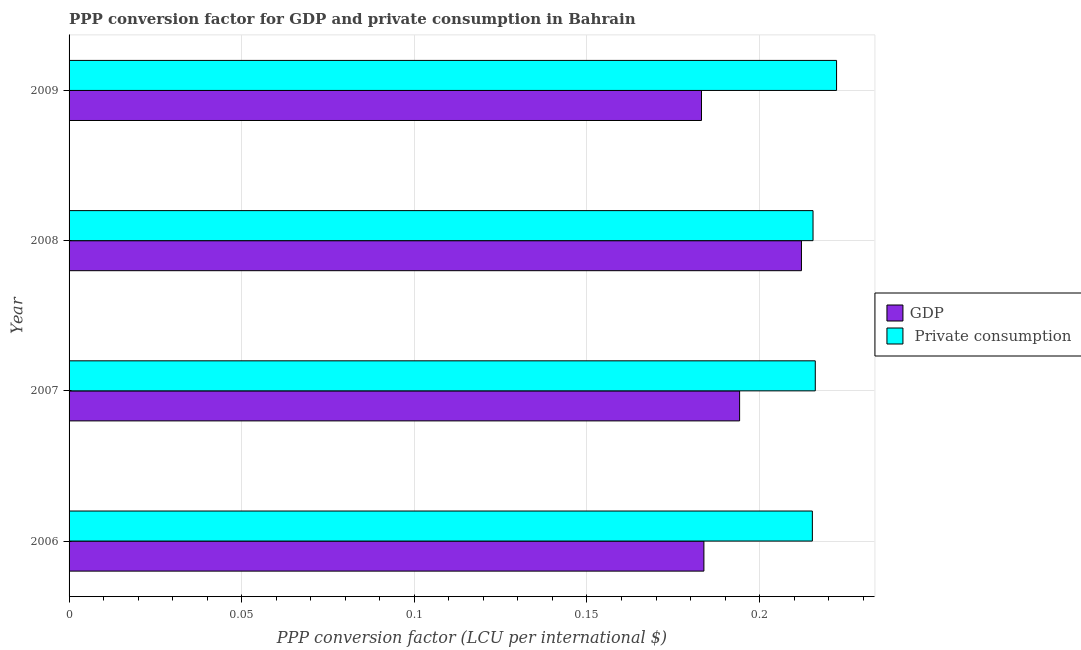How many different coloured bars are there?
Offer a terse response. 2. How many bars are there on the 2nd tick from the bottom?
Your answer should be very brief. 2. In how many cases, is the number of bars for a given year not equal to the number of legend labels?
Keep it short and to the point. 0. What is the ppp conversion factor for private consumption in 2006?
Make the answer very short. 0.22. Across all years, what is the maximum ppp conversion factor for private consumption?
Offer a very short reply. 0.22. Across all years, what is the minimum ppp conversion factor for private consumption?
Offer a terse response. 0.22. What is the total ppp conversion factor for gdp in the graph?
Make the answer very short. 0.77. What is the difference between the ppp conversion factor for private consumption in 2007 and that in 2008?
Your response must be concise. 0. What is the difference between the ppp conversion factor for gdp in 2009 and the ppp conversion factor for private consumption in 2006?
Provide a succinct answer. -0.03. What is the average ppp conversion factor for gdp per year?
Provide a short and direct response. 0.19. In the year 2008, what is the difference between the ppp conversion factor for private consumption and ppp conversion factor for gdp?
Your answer should be very brief. 0. What is the ratio of the ppp conversion factor for gdp in 2006 to that in 2009?
Ensure brevity in your answer.  1. Is the ppp conversion factor for gdp in 2007 less than that in 2009?
Your answer should be very brief. No. Is the difference between the ppp conversion factor for gdp in 2008 and 2009 greater than the difference between the ppp conversion factor for private consumption in 2008 and 2009?
Offer a terse response. Yes. What is the difference between the highest and the second highest ppp conversion factor for gdp?
Offer a very short reply. 0.02. What is the difference between the highest and the lowest ppp conversion factor for gdp?
Give a very brief answer. 0.03. In how many years, is the ppp conversion factor for gdp greater than the average ppp conversion factor for gdp taken over all years?
Provide a succinct answer. 2. What does the 2nd bar from the top in 2007 represents?
Provide a short and direct response. GDP. What does the 2nd bar from the bottom in 2006 represents?
Offer a terse response.  Private consumption. What is the difference between two consecutive major ticks on the X-axis?
Your answer should be very brief. 0.05. Does the graph contain any zero values?
Your answer should be compact. No. How many legend labels are there?
Make the answer very short. 2. What is the title of the graph?
Offer a terse response. PPP conversion factor for GDP and private consumption in Bahrain. Does "US$" appear as one of the legend labels in the graph?
Give a very brief answer. No. What is the label or title of the X-axis?
Your response must be concise. PPP conversion factor (LCU per international $). What is the label or title of the Y-axis?
Give a very brief answer. Year. What is the PPP conversion factor (LCU per international $) of GDP in 2006?
Your answer should be very brief. 0.18. What is the PPP conversion factor (LCU per international $) of  Private consumption in 2006?
Your answer should be compact. 0.22. What is the PPP conversion factor (LCU per international $) in GDP in 2007?
Offer a very short reply. 0.19. What is the PPP conversion factor (LCU per international $) of  Private consumption in 2007?
Offer a terse response. 0.22. What is the PPP conversion factor (LCU per international $) of GDP in 2008?
Give a very brief answer. 0.21. What is the PPP conversion factor (LCU per international $) of  Private consumption in 2008?
Ensure brevity in your answer.  0.22. What is the PPP conversion factor (LCU per international $) in GDP in 2009?
Provide a short and direct response. 0.18. What is the PPP conversion factor (LCU per international $) in  Private consumption in 2009?
Your answer should be very brief. 0.22. Across all years, what is the maximum PPP conversion factor (LCU per international $) in GDP?
Offer a terse response. 0.21. Across all years, what is the maximum PPP conversion factor (LCU per international $) of  Private consumption?
Your response must be concise. 0.22. Across all years, what is the minimum PPP conversion factor (LCU per international $) of GDP?
Provide a short and direct response. 0.18. Across all years, what is the minimum PPP conversion factor (LCU per international $) of  Private consumption?
Your answer should be very brief. 0.22. What is the total PPP conversion factor (LCU per international $) of GDP in the graph?
Your response must be concise. 0.77. What is the total PPP conversion factor (LCU per international $) in  Private consumption in the graph?
Your answer should be very brief. 0.87. What is the difference between the PPP conversion factor (LCU per international $) in GDP in 2006 and that in 2007?
Make the answer very short. -0.01. What is the difference between the PPP conversion factor (LCU per international $) in  Private consumption in 2006 and that in 2007?
Provide a succinct answer. -0. What is the difference between the PPP conversion factor (LCU per international $) in GDP in 2006 and that in 2008?
Your answer should be very brief. -0.03. What is the difference between the PPP conversion factor (LCU per international $) of  Private consumption in 2006 and that in 2008?
Keep it short and to the point. -0. What is the difference between the PPP conversion factor (LCU per international $) in GDP in 2006 and that in 2009?
Keep it short and to the point. 0. What is the difference between the PPP conversion factor (LCU per international $) of  Private consumption in 2006 and that in 2009?
Provide a short and direct response. -0.01. What is the difference between the PPP conversion factor (LCU per international $) of GDP in 2007 and that in 2008?
Your response must be concise. -0.02. What is the difference between the PPP conversion factor (LCU per international $) in  Private consumption in 2007 and that in 2008?
Give a very brief answer. 0. What is the difference between the PPP conversion factor (LCU per international $) of GDP in 2007 and that in 2009?
Give a very brief answer. 0.01. What is the difference between the PPP conversion factor (LCU per international $) of  Private consumption in 2007 and that in 2009?
Keep it short and to the point. -0.01. What is the difference between the PPP conversion factor (LCU per international $) of GDP in 2008 and that in 2009?
Your answer should be compact. 0.03. What is the difference between the PPP conversion factor (LCU per international $) of  Private consumption in 2008 and that in 2009?
Provide a short and direct response. -0.01. What is the difference between the PPP conversion factor (LCU per international $) in GDP in 2006 and the PPP conversion factor (LCU per international $) in  Private consumption in 2007?
Give a very brief answer. -0.03. What is the difference between the PPP conversion factor (LCU per international $) of GDP in 2006 and the PPP conversion factor (LCU per international $) of  Private consumption in 2008?
Keep it short and to the point. -0.03. What is the difference between the PPP conversion factor (LCU per international $) of GDP in 2006 and the PPP conversion factor (LCU per international $) of  Private consumption in 2009?
Your answer should be very brief. -0.04. What is the difference between the PPP conversion factor (LCU per international $) of GDP in 2007 and the PPP conversion factor (LCU per international $) of  Private consumption in 2008?
Your response must be concise. -0.02. What is the difference between the PPP conversion factor (LCU per international $) in GDP in 2007 and the PPP conversion factor (LCU per international $) in  Private consumption in 2009?
Offer a terse response. -0.03. What is the difference between the PPP conversion factor (LCU per international $) of GDP in 2008 and the PPP conversion factor (LCU per international $) of  Private consumption in 2009?
Your answer should be very brief. -0.01. What is the average PPP conversion factor (LCU per international $) in GDP per year?
Offer a very short reply. 0.19. What is the average PPP conversion factor (LCU per international $) of  Private consumption per year?
Your answer should be very brief. 0.22. In the year 2006, what is the difference between the PPP conversion factor (LCU per international $) of GDP and PPP conversion factor (LCU per international $) of  Private consumption?
Offer a terse response. -0.03. In the year 2007, what is the difference between the PPP conversion factor (LCU per international $) in GDP and PPP conversion factor (LCU per international $) in  Private consumption?
Provide a short and direct response. -0.02. In the year 2008, what is the difference between the PPP conversion factor (LCU per international $) of GDP and PPP conversion factor (LCU per international $) of  Private consumption?
Provide a short and direct response. -0. In the year 2009, what is the difference between the PPP conversion factor (LCU per international $) in GDP and PPP conversion factor (LCU per international $) in  Private consumption?
Your response must be concise. -0.04. What is the ratio of the PPP conversion factor (LCU per international $) of GDP in 2006 to that in 2007?
Offer a very short reply. 0.95. What is the ratio of the PPP conversion factor (LCU per international $) in GDP in 2006 to that in 2008?
Provide a short and direct response. 0.87. What is the ratio of the PPP conversion factor (LCU per international $) of  Private consumption in 2006 to that in 2008?
Ensure brevity in your answer.  1. What is the ratio of the PPP conversion factor (LCU per international $) of GDP in 2006 to that in 2009?
Your answer should be compact. 1. What is the ratio of the PPP conversion factor (LCU per international $) of  Private consumption in 2006 to that in 2009?
Ensure brevity in your answer.  0.97. What is the ratio of the PPP conversion factor (LCU per international $) of GDP in 2007 to that in 2008?
Keep it short and to the point. 0.92. What is the ratio of the PPP conversion factor (LCU per international $) of GDP in 2007 to that in 2009?
Provide a short and direct response. 1.06. What is the ratio of the PPP conversion factor (LCU per international $) of  Private consumption in 2007 to that in 2009?
Provide a short and direct response. 0.97. What is the ratio of the PPP conversion factor (LCU per international $) in GDP in 2008 to that in 2009?
Offer a very short reply. 1.16. What is the ratio of the PPP conversion factor (LCU per international $) of  Private consumption in 2008 to that in 2009?
Provide a short and direct response. 0.97. What is the difference between the highest and the second highest PPP conversion factor (LCU per international $) in GDP?
Offer a very short reply. 0.02. What is the difference between the highest and the second highest PPP conversion factor (LCU per international $) in  Private consumption?
Make the answer very short. 0.01. What is the difference between the highest and the lowest PPP conversion factor (LCU per international $) in GDP?
Offer a terse response. 0.03. What is the difference between the highest and the lowest PPP conversion factor (LCU per international $) of  Private consumption?
Offer a terse response. 0.01. 